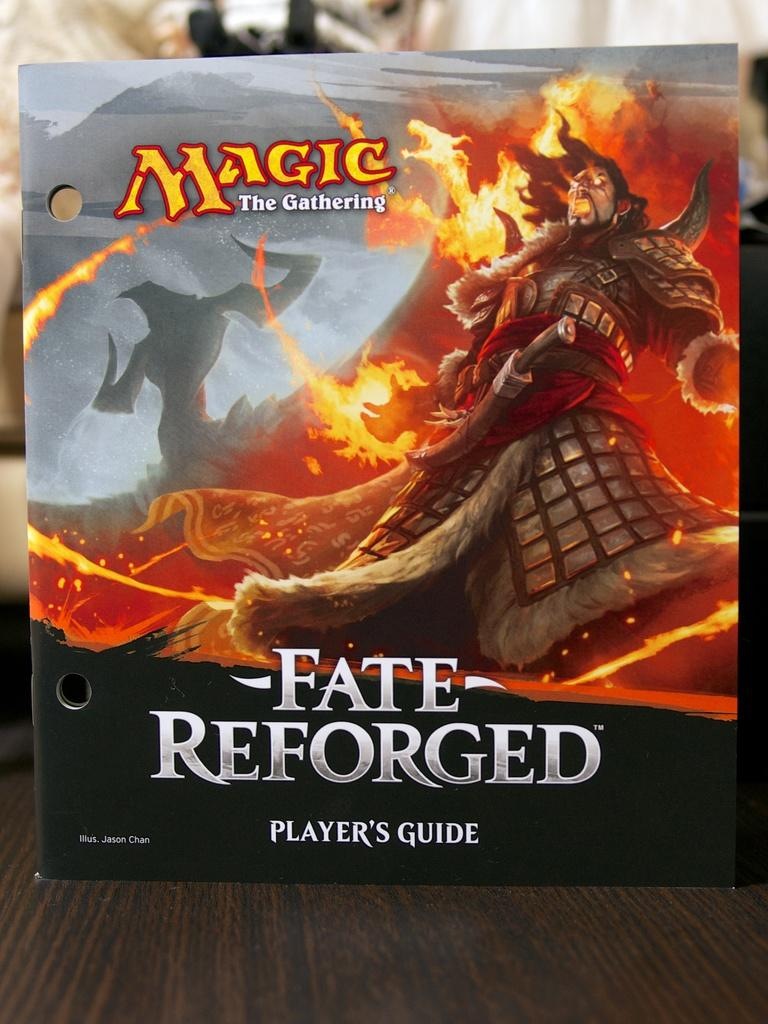<image>
Render a clear and concise summary of the photo. player's guide for magic the gathering fate reforged standing up on a table 